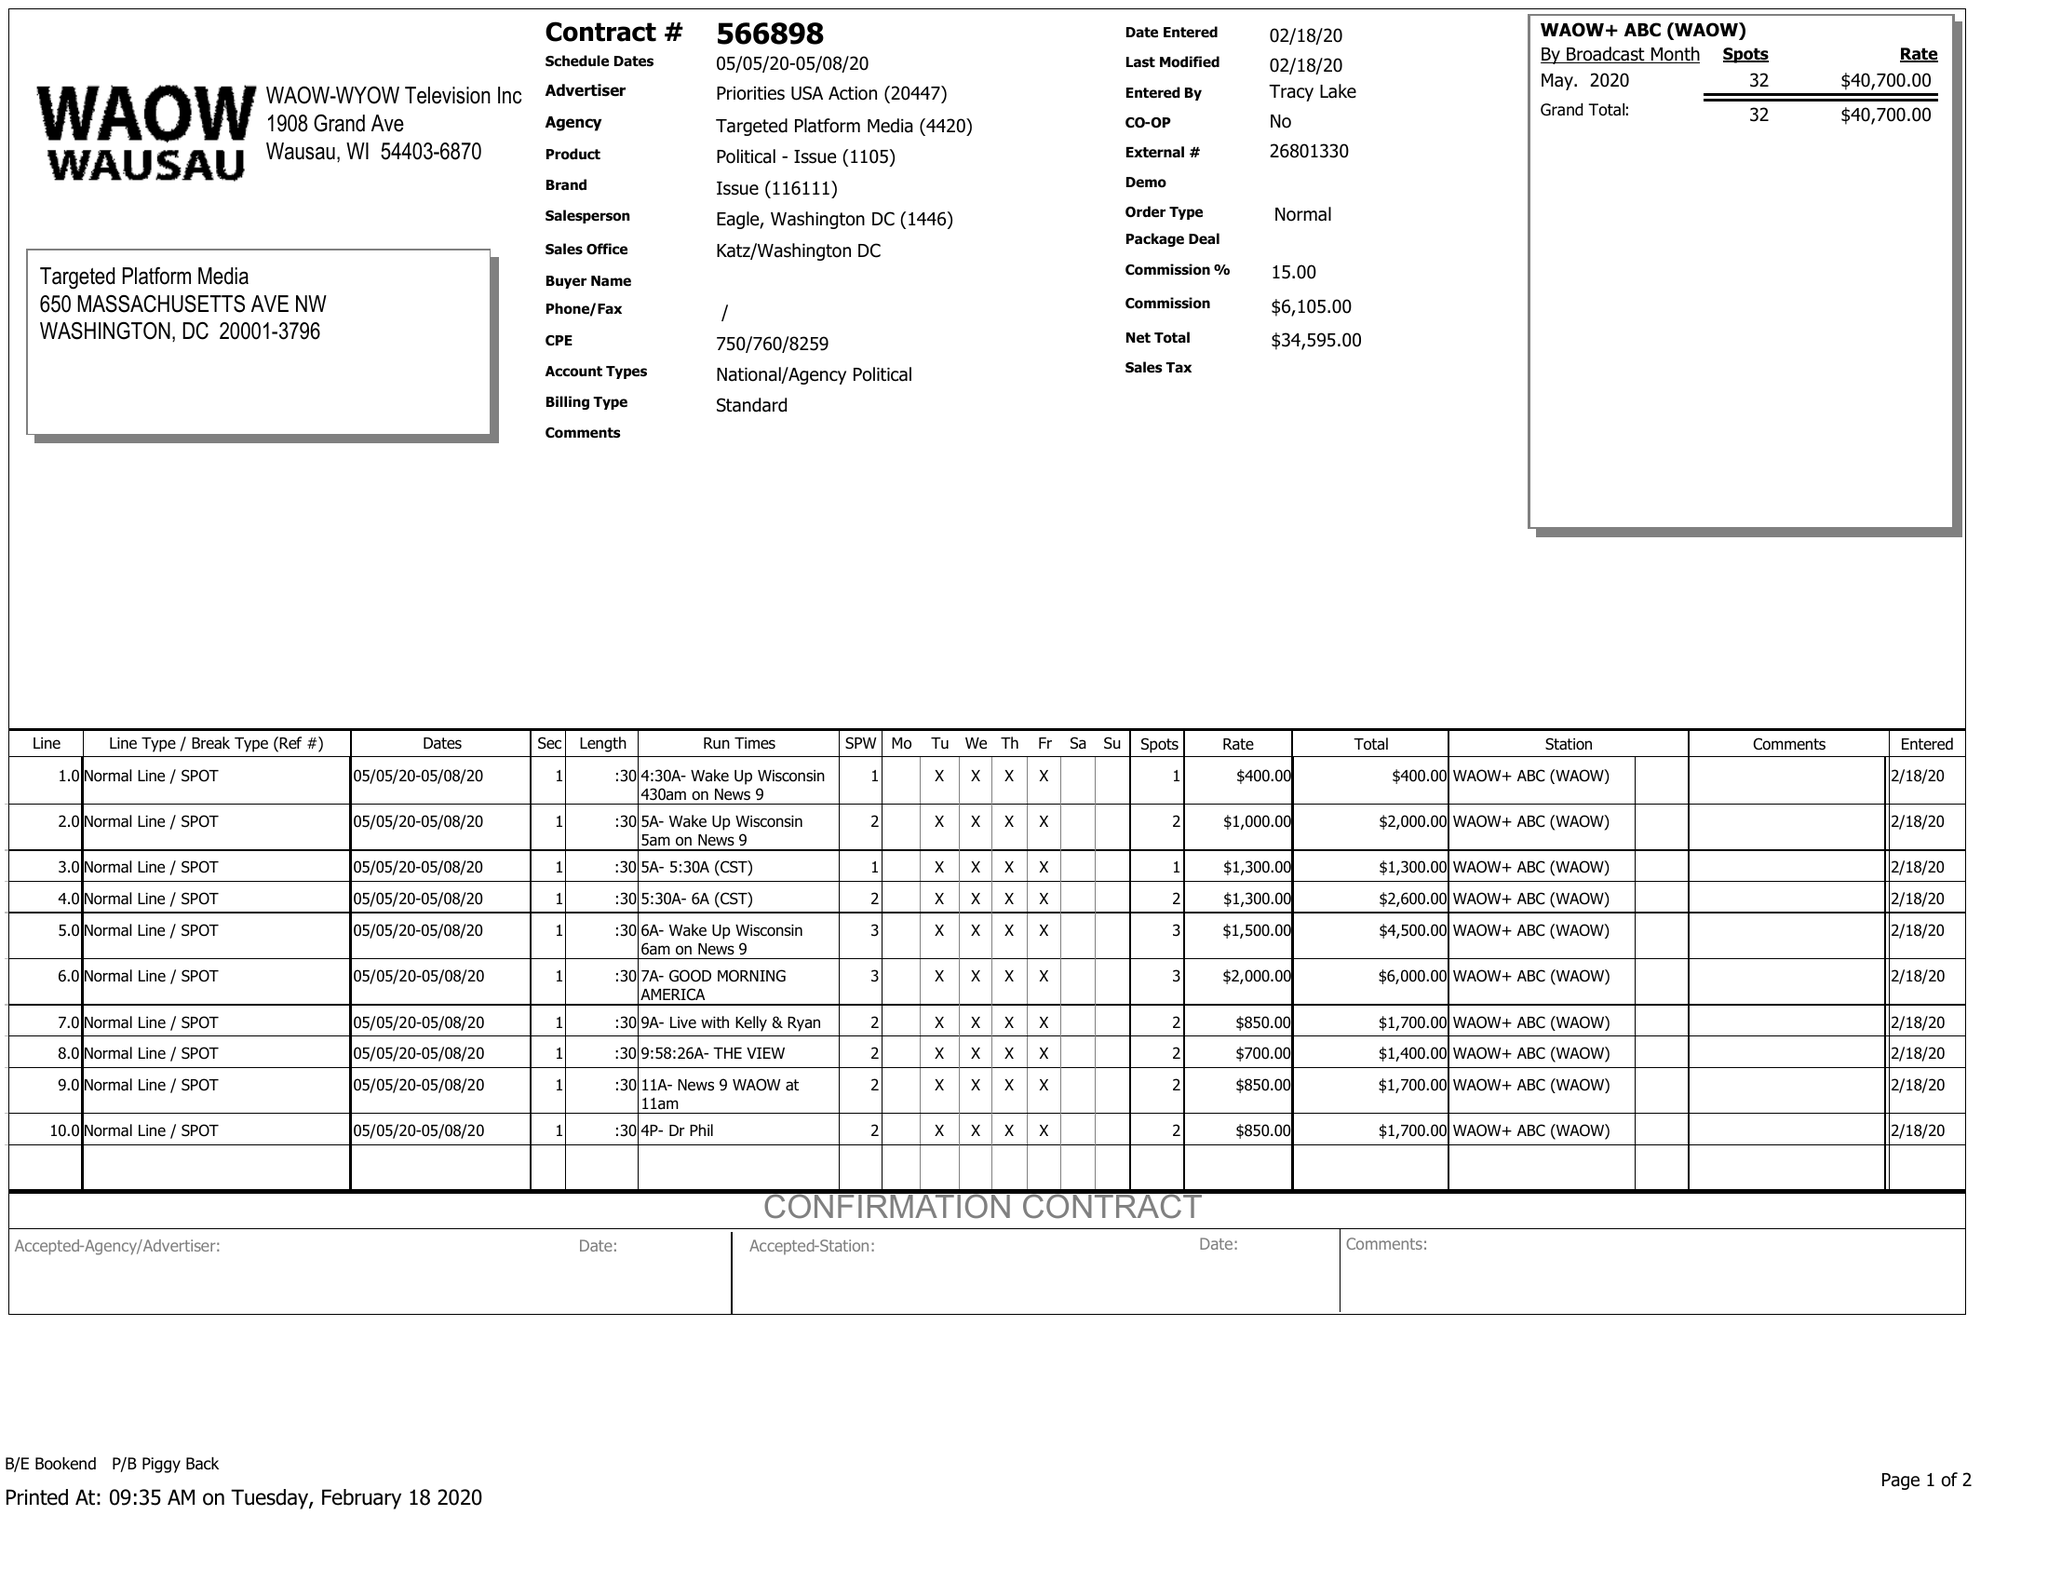What is the value for the advertiser?
Answer the question using a single word or phrase. PRIORITIES USA ACTIO 